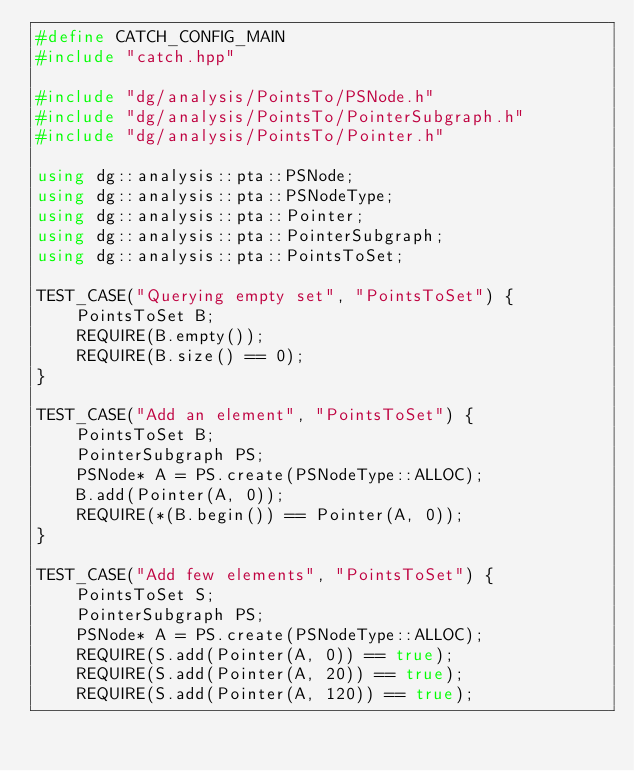Convert code to text. <code><loc_0><loc_0><loc_500><loc_500><_C++_>#define CATCH_CONFIG_MAIN
#include "catch.hpp"

#include "dg/analysis/PointsTo/PSNode.h"
#include "dg/analysis/PointsTo/PointerSubgraph.h"
#include "dg/analysis/PointsTo/Pointer.h"

using dg::analysis::pta::PSNode;
using dg::analysis::pta::PSNodeType;
using dg::analysis::pta::Pointer;
using dg::analysis::pta::PointerSubgraph;
using dg::analysis::pta::PointsToSet;

TEST_CASE("Querying empty set", "PointsToSet") {
    PointsToSet B;
    REQUIRE(B.empty());
    REQUIRE(B.size() == 0);
}

TEST_CASE("Add an element", "PointsToSet") {
    PointsToSet B;
    PointerSubgraph PS;
    PSNode* A = PS.create(PSNodeType::ALLOC);
    B.add(Pointer(A, 0));
    REQUIRE(*(B.begin()) == Pointer(A, 0));
}

TEST_CASE("Add few elements", "PointsToSet") {
    PointsToSet S;
    PointerSubgraph PS;
    PSNode* A = PS.create(PSNodeType::ALLOC);
    REQUIRE(S.add(Pointer(A, 0)) == true);
    REQUIRE(S.add(Pointer(A, 20)) == true);
    REQUIRE(S.add(Pointer(A, 120)) == true);</code> 